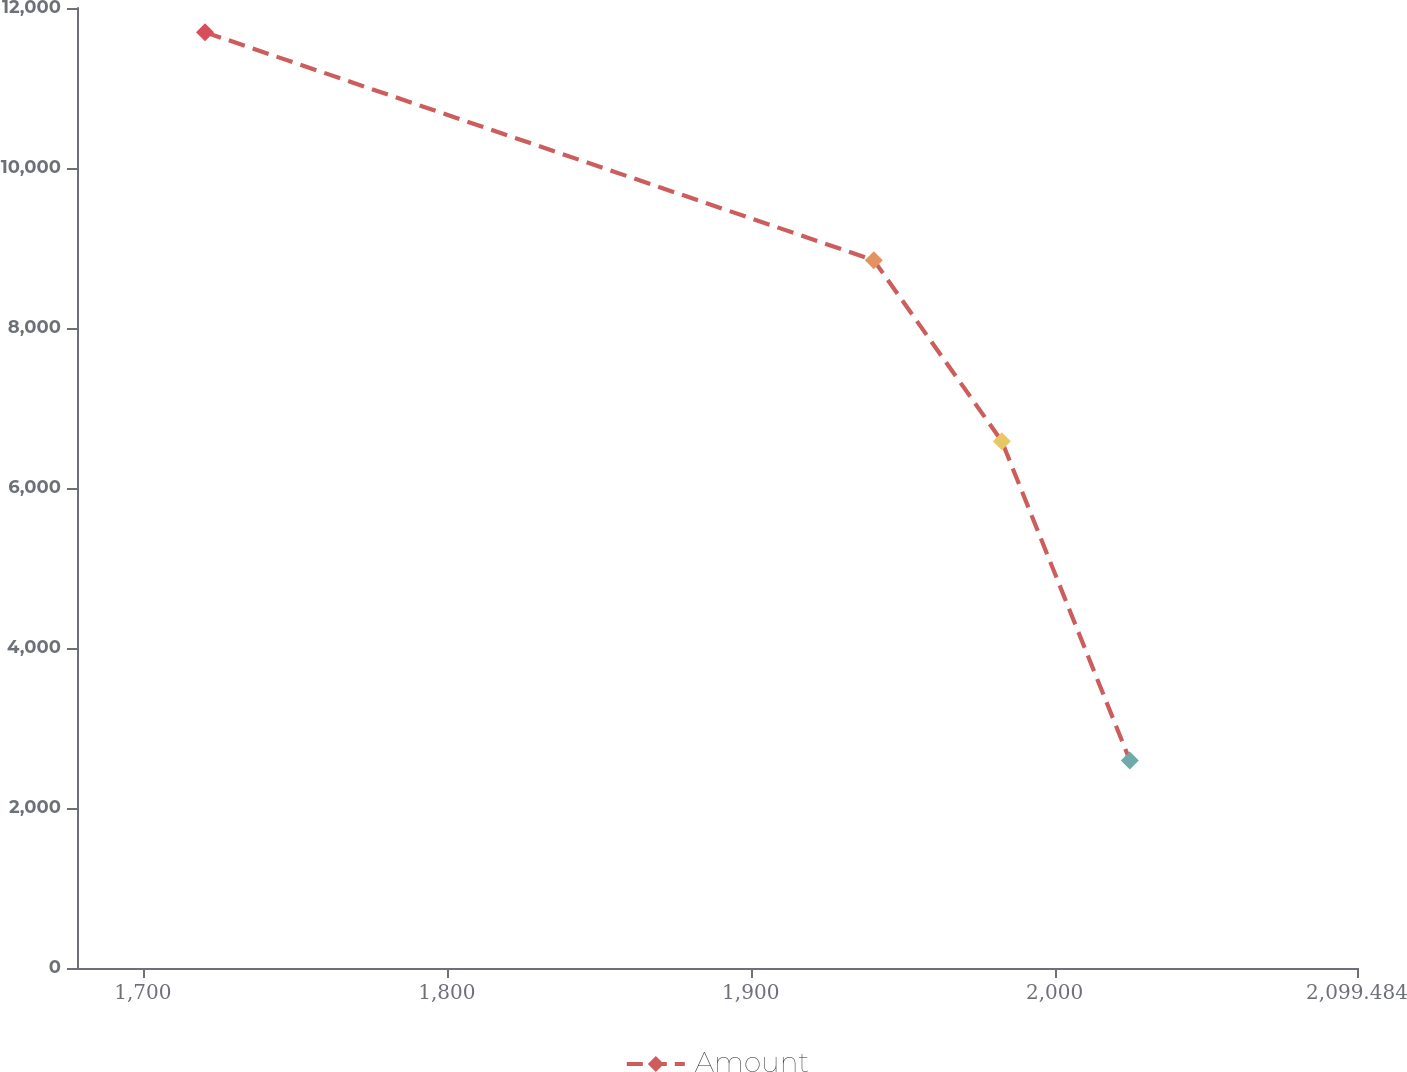Convert chart to OTSL. <chart><loc_0><loc_0><loc_500><loc_500><line_chart><ecel><fcel>Amount<nl><fcel>1720.44<fcel>11697.1<nl><fcel>1940.5<fcel>8847.01<nl><fcel>1982.62<fcel>6585.19<nl><fcel>2024.74<fcel>2595.18<nl><fcel>2141.6<fcel>1583.85<nl></chart> 